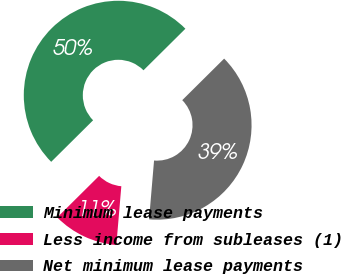Convert chart to OTSL. <chart><loc_0><loc_0><loc_500><loc_500><pie_chart><fcel>Minimum lease payments<fcel>Less income from subleases (1)<fcel>Net minimum lease payments<nl><fcel>50.0%<fcel>11.22%<fcel>38.78%<nl></chart> 